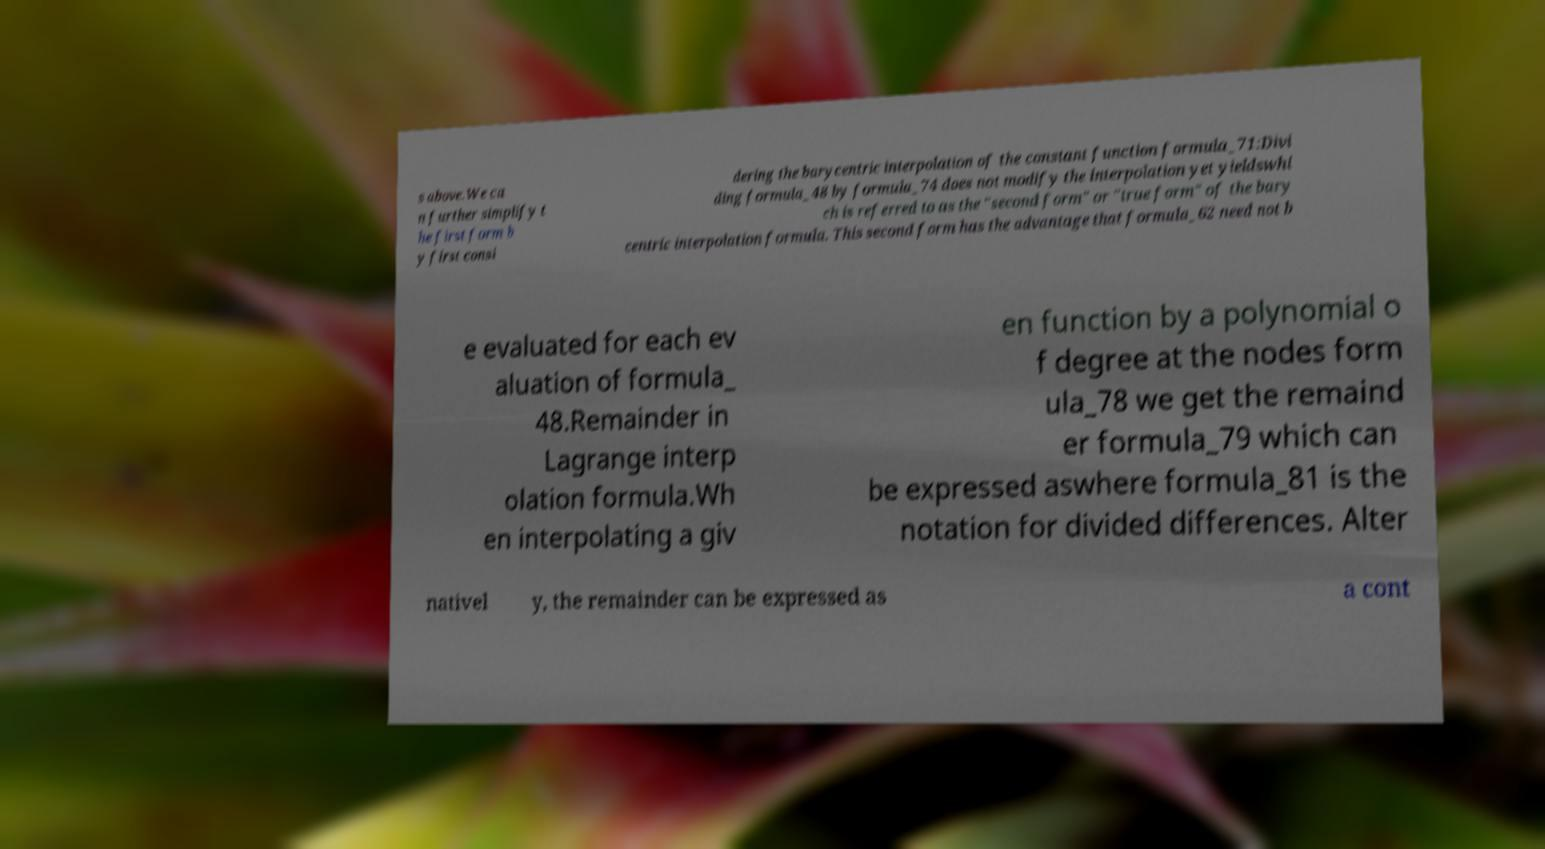There's text embedded in this image that I need extracted. Can you transcribe it verbatim? s above.We ca n further simplify t he first form b y first consi dering the barycentric interpolation of the constant function formula_71:Divi ding formula_48 by formula_74 does not modify the interpolation yet yieldswhi ch is referred to as the "second form" or "true form" of the bary centric interpolation formula. This second form has the advantage that formula_62 need not b e evaluated for each ev aluation of formula_ 48.Remainder in Lagrange interp olation formula.Wh en interpolating a giv en function by a polynomial o f degree at the nodes form ula_78 we get the remaind er formula_79 which can be expressed aswhere formula_81 is the notation for divided differences. Alter nativel y, the remainder can be expressed as a cont 